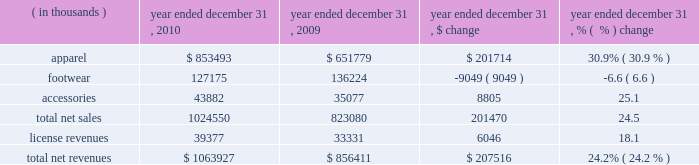Year ended december 31 , 2010 compared to year ended december 31 , 2009 net revenues increased $ 207.5 million , or 24.2% ( 24.2 % ) , to $ 1063.9 million in 2010 from $ 856.4 million in 2009 .
Net revenues by product category are summarized below: .
Net sales increased $ 201.5 million , or 24.5% ( 24.5 % ) , to $ 1024.6 million in 2010 from $ 823.1 million in 2009 as noted in the table above .
The increase in net sales primarily reflects : 2022 $ 88.9 million , or 56.8% ( 56.8 % ) , increase in direct to consumer sales , which includes 19 additional stores in 2010 ; and 2022 unit growth driven by increased distribution and new offerings in multiple product categories , most significantly in our training , base layer , mountain , golf and underwear categories ; partially offset by 2022 $ 9.0 million decrease in footwear sales driven primarily by a decline in running and training footwear sales .
License revenues increased $ 6.1 million , or 18.1% ( 18.1 % ) , to $ 39.4 million in 2010 from $ 33.3 million in 2009 .
This increase in license revenues was primarily a result of increased sales by our licensees due to increased distribution and continued unit volume growth .
We have developed our own headwear and bags , and beginning in 2011 , these products are being sold by us rather than by one of our licensees .
Gross profit increased $ 120.4 million to $ 530.5 million in 2010 from $ 410.1 million in 2009 .
Gross profit as a percentage of net revenues , or gross margin , increased 200 basis points to 49.9% ( 49.9 % ) in 2010 compared to 47.9% ( 47.9 % ) in 2009 .
The increase in gross margin percentage was primarily driven by the following : 2022 approximate 100 basis point increase driven by increased direct to consumer higher margin sales ; 2022 approximate 50 basis point increase driven by decreased sales markdowns and returns , primarily due to improved sell-through rates at retail ; and 2022 approximate 50 basis point increase driven primarily by liquidation sales and related inventory reserve reversals .
The current year period benefited from reversals of inventory reserves established in the prior year relative to certain cleated footwear , sport specific apparel and gloves .
These products have historically been more difficult to liquidate at favorable prices .
Selling , general and administrative expenses increased $ 93.3 million to $ 418.2 million in 2010 from $ 324.9 million in 2009 .
As a percentage of net revenues , selling , general and administrative expenses increased to 39.3% ( 39.3 % ) in 2010 from 37.9% ( 37.9 % ) in 2009 .
These changes were primarily attributable to the following : 2022 marketing costs increased $ 19.3 million to $ 128.2 million in 2010 from $ 108.9 million in 2009 primarily due to an increase in sponsorship of events and collegiate and professional teams and athletes , increased television and digital campaign costs , including media campaigns for specific customers and additional personnel costs .
In addition , we incurred increased expenses for our performance incentive plan as compared to the prior year .
As a percentage of net revenues , marketing costs decreased to 12.0% ( 12.0 % ) in 2010 from 12.7% ( 12.7 % ) in 2009 primarily due to decreased marketing costs for specific customers. .
What was the percentage change in the gross profit from 2009 to 2010 \\n? 
Computations: ((530.5 - 120.4) / 120.4)
Answer: 3.40615. 